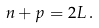Convert formula to latex. <formula><loc_0><loc_0><loc_500><loc_500>n + p = 2 L \, .</formula> 